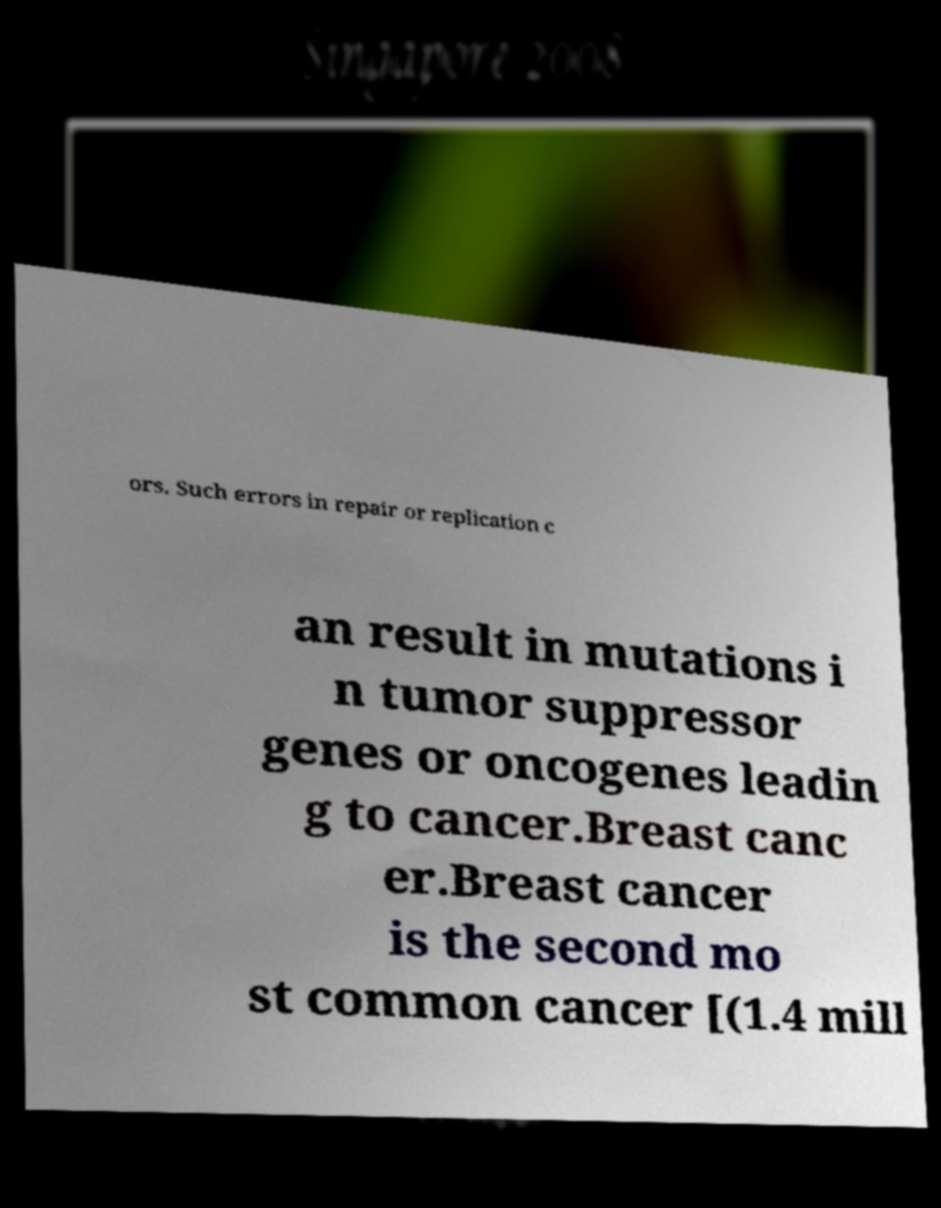I need the written content from this picture converted into text. Can you do that? ors. Such errors in repair or replication c an result in mutations i n tumor suppressor genes or oncogenes leadin g to cancer.Breast canc er.Breast cancer is the second mo st common cancer [(1.4 mill 